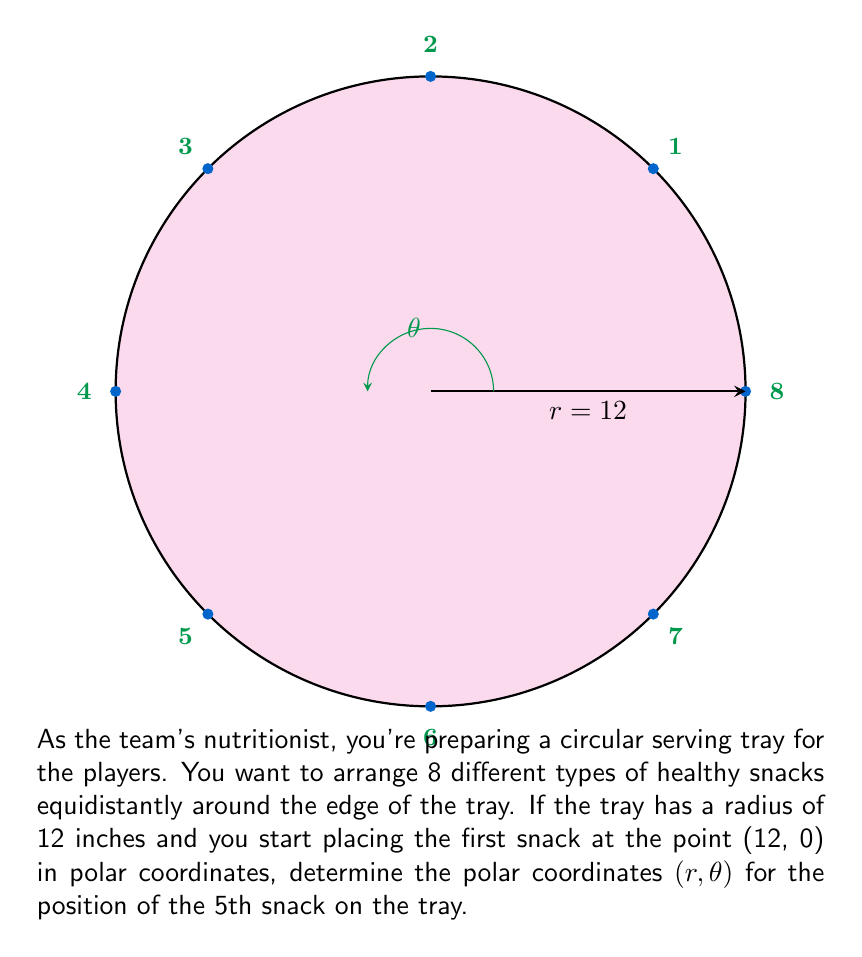Show me your answer to this math problem. Let's approach this step-by-step:

1) First, we need to understand that the snacks will be arranged in a circular pattern, forming a regular octagon.

2) In a circle, there are 360° or 2π radians. With 8 snacks, the angle between each snack will be:

   $$\theta_{between} = \frac{360°}{8} = 45°$$ or $$\frac{2\pi}{8} = \frac{\pi}{4}$$ radians

3) The 5th snack will be 4 positions away from the first snack (as we count the first snack as position 0). So, the angle for the 5th snack will be:

   $$\theta_5 = 4 \times 45° = 180°$$ or $$4 \times \frac{\pi}{4} = \pi$$ radians

4) The radius remains constant at 12 inches for all snacks as they are placed on the edge of the tray.

5) Therefore, the polar coordinates (r, θ) for the 5th snack are:

   $$(r, \theta) = (12, \pi)$$ or $$(12, 180°)$$
Answer: (12, π) radians or (12, 180°) 